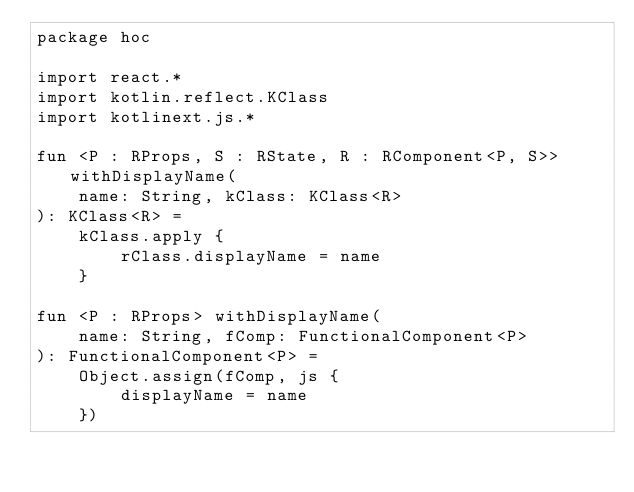Convert code to text. <code><loc_0><loc_0><loc_500><loc_500><_Kotlin_>package hoc

import react.*
import kotlin.reflect.KClass
import kotlinext.js.*

fun <P : RProps, S : RState, R : RComponent<P, S>> withDisplayName(
    name: String, kClass: KClass<R>
): KClass<R> =
    kClass.apply {
        rClass.displayName = name
    }

fun <P : RProps> withDisplayName(
    name: String, fComp: FunctionalComponent<P>
): FunctionalComponent<P> =
    Object.assign(fComp, js {
        displayName = name
    })</code> 